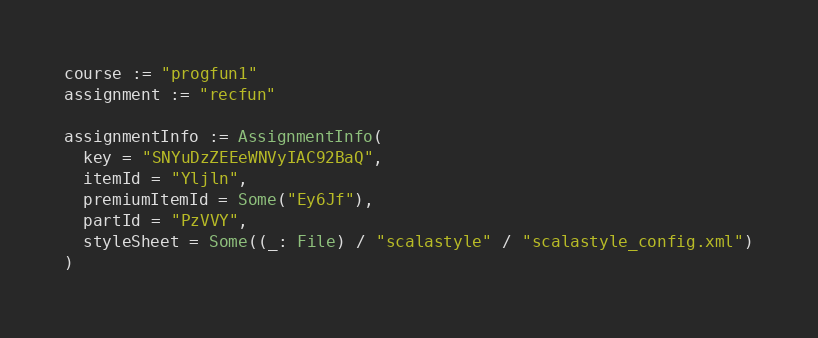Convert code to text. <code><loc_0><loc_0><loc_500><loc_500><_Scala_>course := "progfun1"
assignment := "recfun"

assignmentInfo := AssignmentInfo(
  key = "SNYuDzZEEeWNVyIAC92BaQ",
  itemId = "Yljln",
  premiumItemId = Some("Ey6Jf"),
  partId = "PzVVY",
  styleSheet = Some((_: File) / "scalastyle" / "scalastyle_config.xml")
)
</code> 